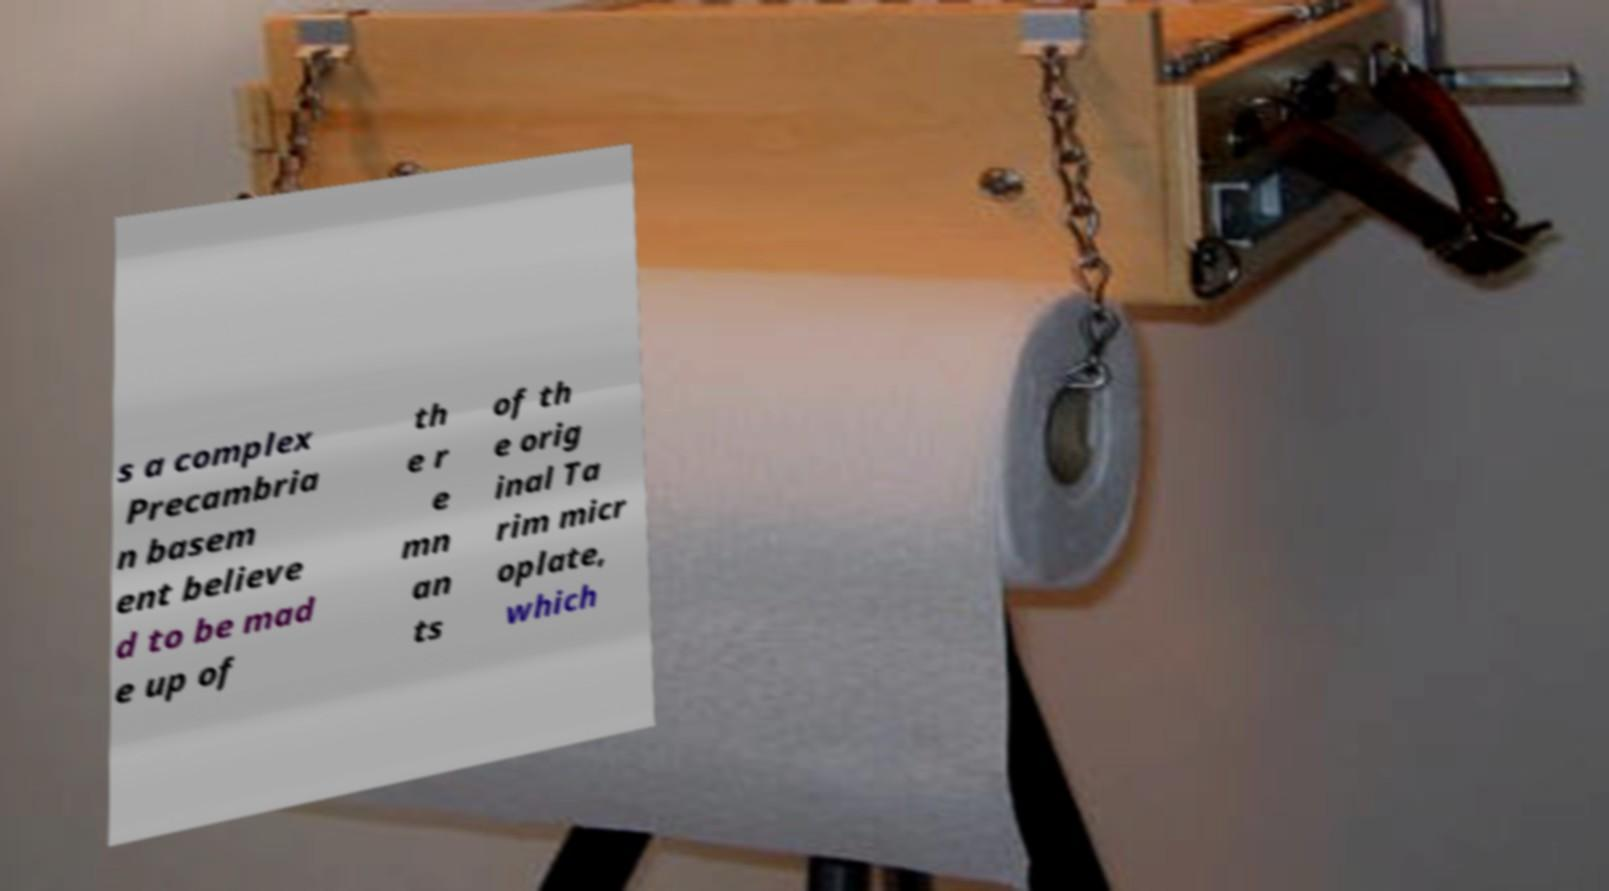There's text embedded in this image that I need extracted. Can you transcribe it verbatim? s a complex Precambria n basem ent believe d to be mad e up of th e r e mn an ts of th e orig inal Ta rim micr oplate, which 